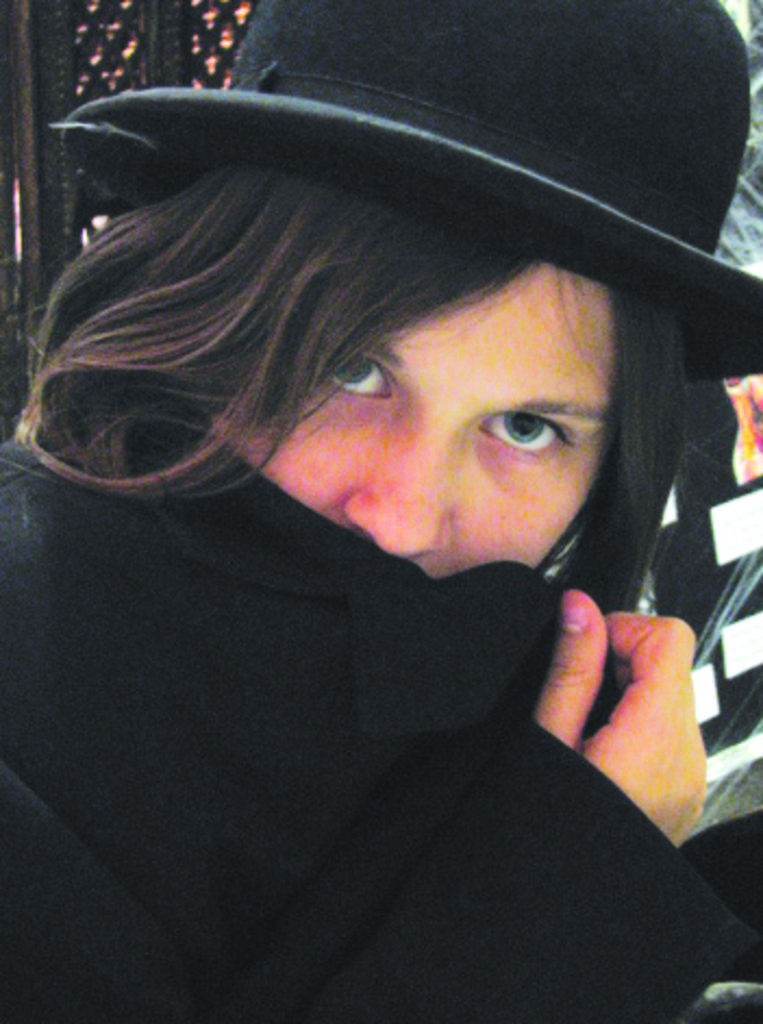Please provide a concise description of this image. In the image we can see a person. Behind the person we can see a banner. 